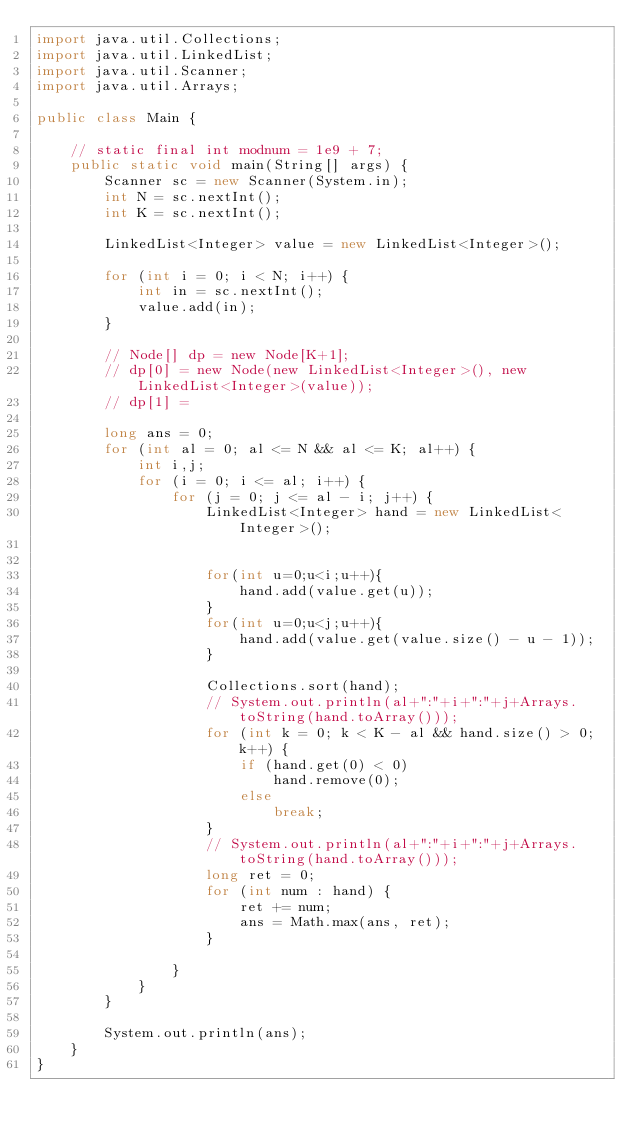Convert code to text. <code><loc_0><loc_0><loc_500><loc_500><_Java_>import java.util.Collections;
import java.util.LinkedList;
import java.util.Scanner;
import java.util.Arrays;

public class Main {

    // static final int modnum = 1e9 + 7;
    public static void main(String[] args) {
        Scanner sc = new Scanner(System.in);
        int N = sc.nextInt();
        int K = sc.nextInt();

        LinkedList<Integer> value = new LinkedList<Integer>();

        for (int i = 0; i < N; i++) {
            int in = sc.nextInt();
            value.add(in);
        }

        // Node[] dp = new Node[K+1];
        // dp[0] = new Node(new LinkedList<Integer>(), new LinkedList<Integer>(value));
        // dp[1] =

        long ans = 0;
        for (int al = 0; al <= N && al <= K; al++) {
            int i,j;
            for (i = 0; i <= al; i++) {
                for (j = 0; j <= al - i; j++) {
                    LinkedList<Integer> hand = new LinkedList<Integer>();
                    
                    
                    for(int u=0;u<i;u++){
                        hand.add(value.get(u));
                    }
                    for(int u=0;u<j;u++){
                        hand.add(value.get(value.size() - u - 1));
                    }

                    Collections.sort(hand);
                    // System.out.println(al+":"+i+":"+j+Arrays.toString(hand.toArray()));
                    for (int k = 0; k < K - al && hand.size() > 0; k++) {
                        if (hand.get(0) < 0)
                            hand.remove(0);
                        else
                            break;
                    }
                    // System.out.println(al+":"+i+":"+j+Arrays.toString(hand.toArray()));
                    long ret = 0;
                    for (int num : hand) {
                        ret += num;
                        ans = Math.max(ans, ret);
                    }

                }
            }
        }
        
        System.out.println(ans);
    }
}</code> 